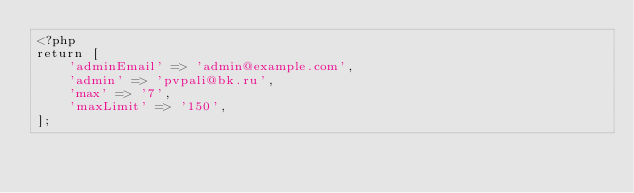<code> <loc_0><loc_0><loc_500><loc_500><_PHP_><?php
return [
    'adminEmail' => 'admin@example.com',
    'admin' => 'pvpali@bk.ru',
    'max' => '7',
    'maxLimit' => '150',
];
</code> 